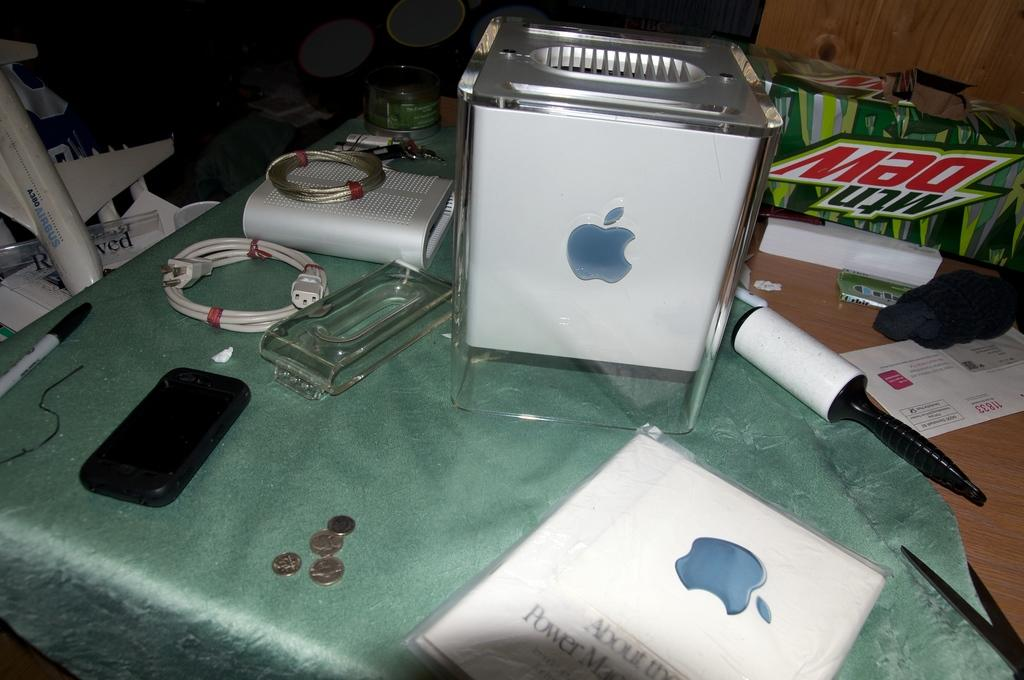<image>
Offer a succinct explanation of the picture presented. a mountain dew box sitting in the back of a table 